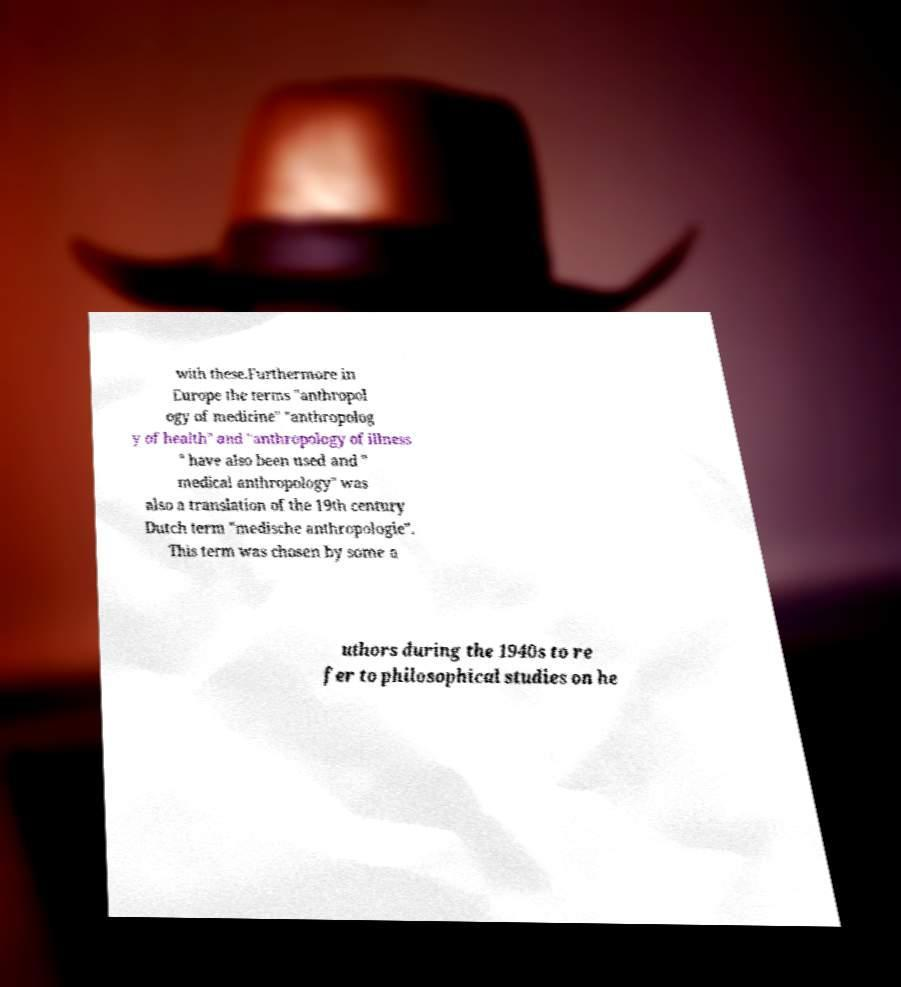What messages or text are displayed in this image? I need them in a readable, typed format. with these.Furthermore in Europe the terms "anthropol ogy of medicine" "anthropolog y of health" and "anthropology of illness " have also been used and " medical anthropology" was also a translation of the 19th century Dutch term "medische anthropologie". This term was chosen by some a uthors during the 1940s to re fer to philosophical studies on he 